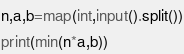Convert code to text. <code><loc_0><loc_0><loc_500><loc_500><_Python_>n,a,b=map(int,input().split())
print(min(n*a,b))
</code> 